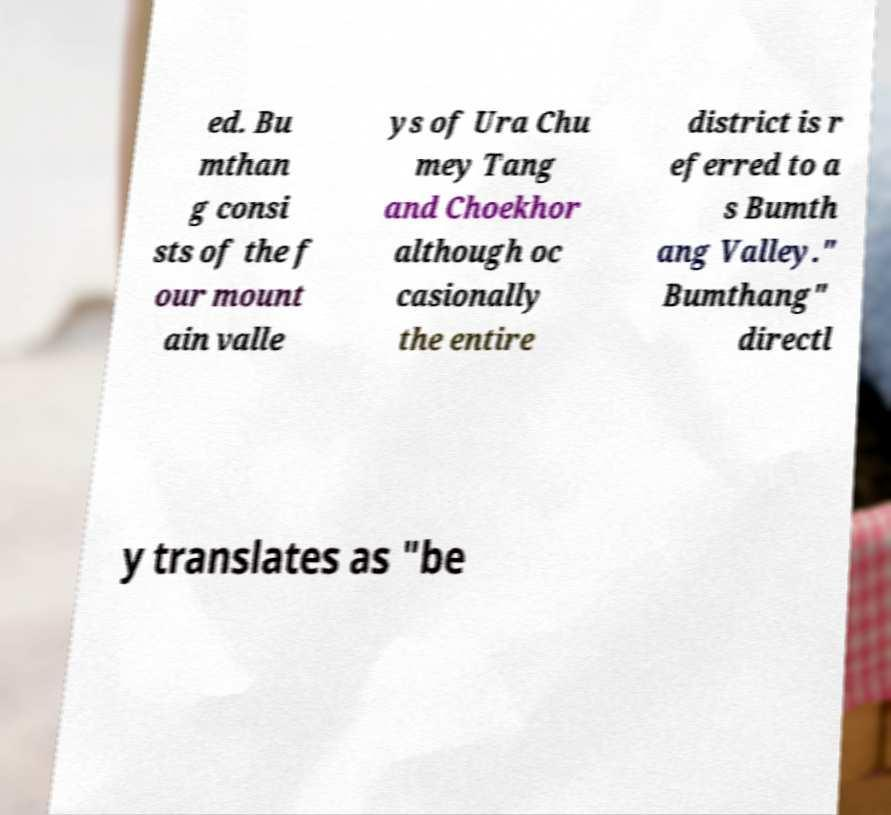Could you assist in decoding the text presented in this image and type it out clearly? ed. Bu mthan g consi sts of the f our mount ain valle ys of Ura Chu mey Tang and Choekhor although oc casionally the entire district is r eferred to a s Bumth ang Valley." Bumthang" directl y translates as "be 